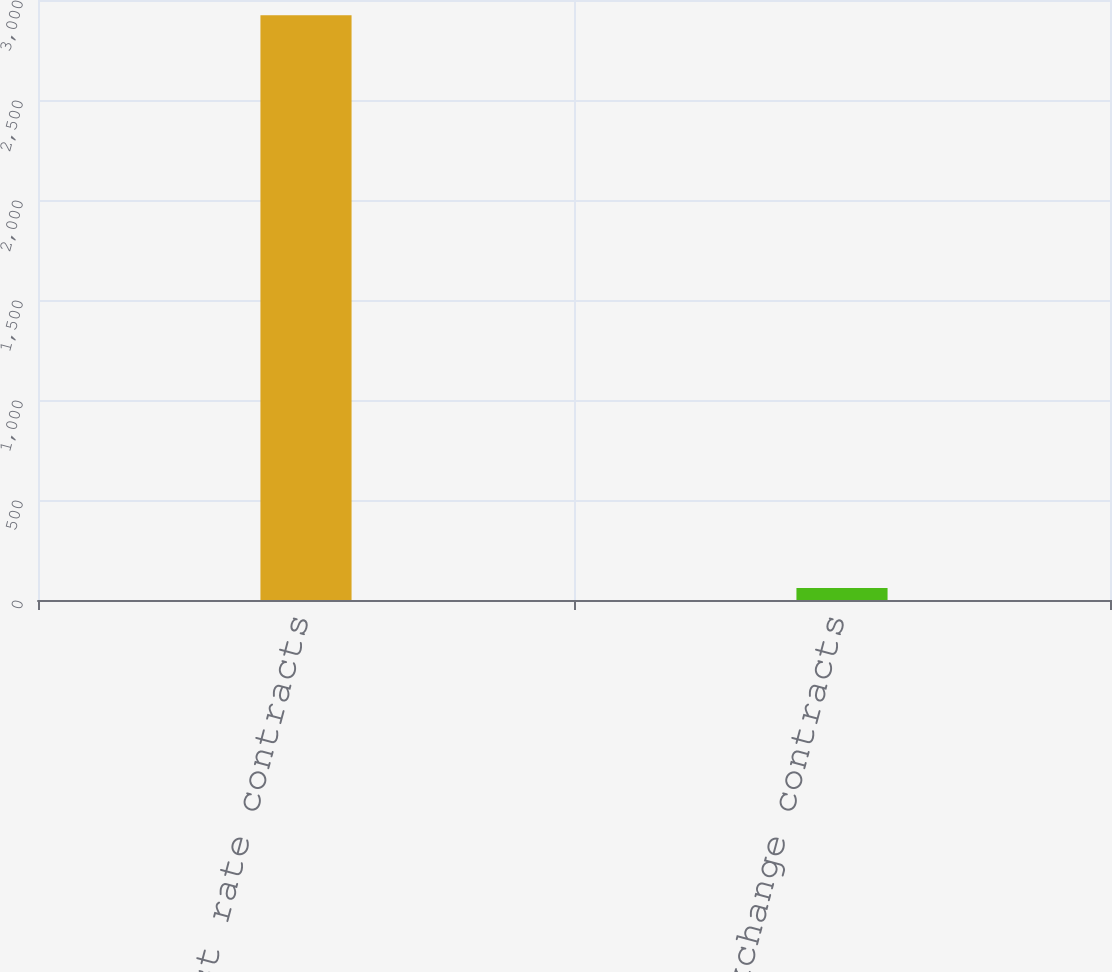Convert chart. <chart><loc_0><loc_0><loc_500><loc_500><bar_chart><fcel>Interest rate contracts<fcel>Currency exchange contracts<nl><fcel>2924<fcel>60<nl></chart> 